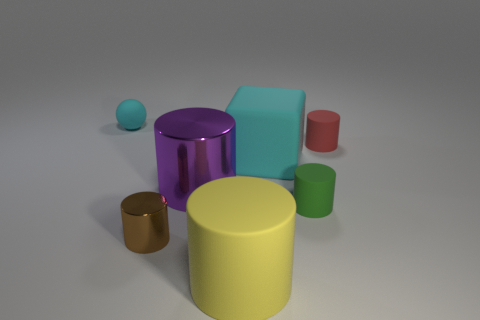Subtract all yellow cylinders. How many cylinders are left? 4 Subtract all brown cylinders. How many cylinders are left? 4 Subtract all blue cylinders. Subtract all purple spheres. How many cylinders are left? 5 Add 2 big brown objects. How many objects exist? 9 Subtract all cylinders. How many objects are left? 2 Add 7 small red cylinders. How many small red cylinders are left? 8 Add 2 large green spheres. How many large green spheres exist? 2 Subtract 0 yellow balls. How many objects are left? 7 Subtract all purple metallic balls. Subtract all large objects. How many objects are left? 4 